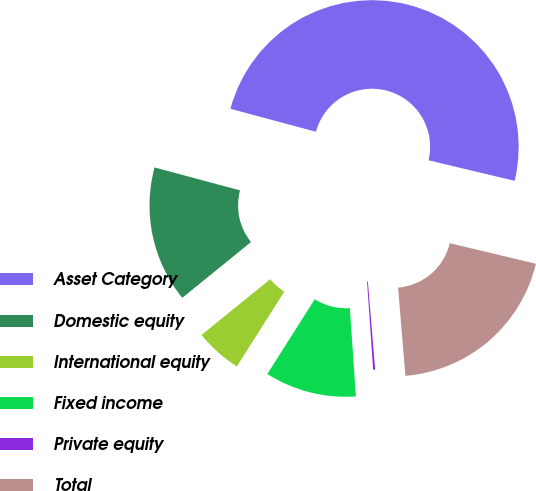Convert chart to OTSL. <chart><loc_0><loc_0><loc_500><loc_500><pie_chart><fcel>Asset Category<fcel>Domestic equity<fcel>International equity<fcel>Fixed income<fcel>Private equity<fcel>Total<nl><fcel>49.55%<fcel>15.02%<fcel>5.16%<fcel>10.09%<fcel>0.22%<fcel>19.96%<nl></chart> 